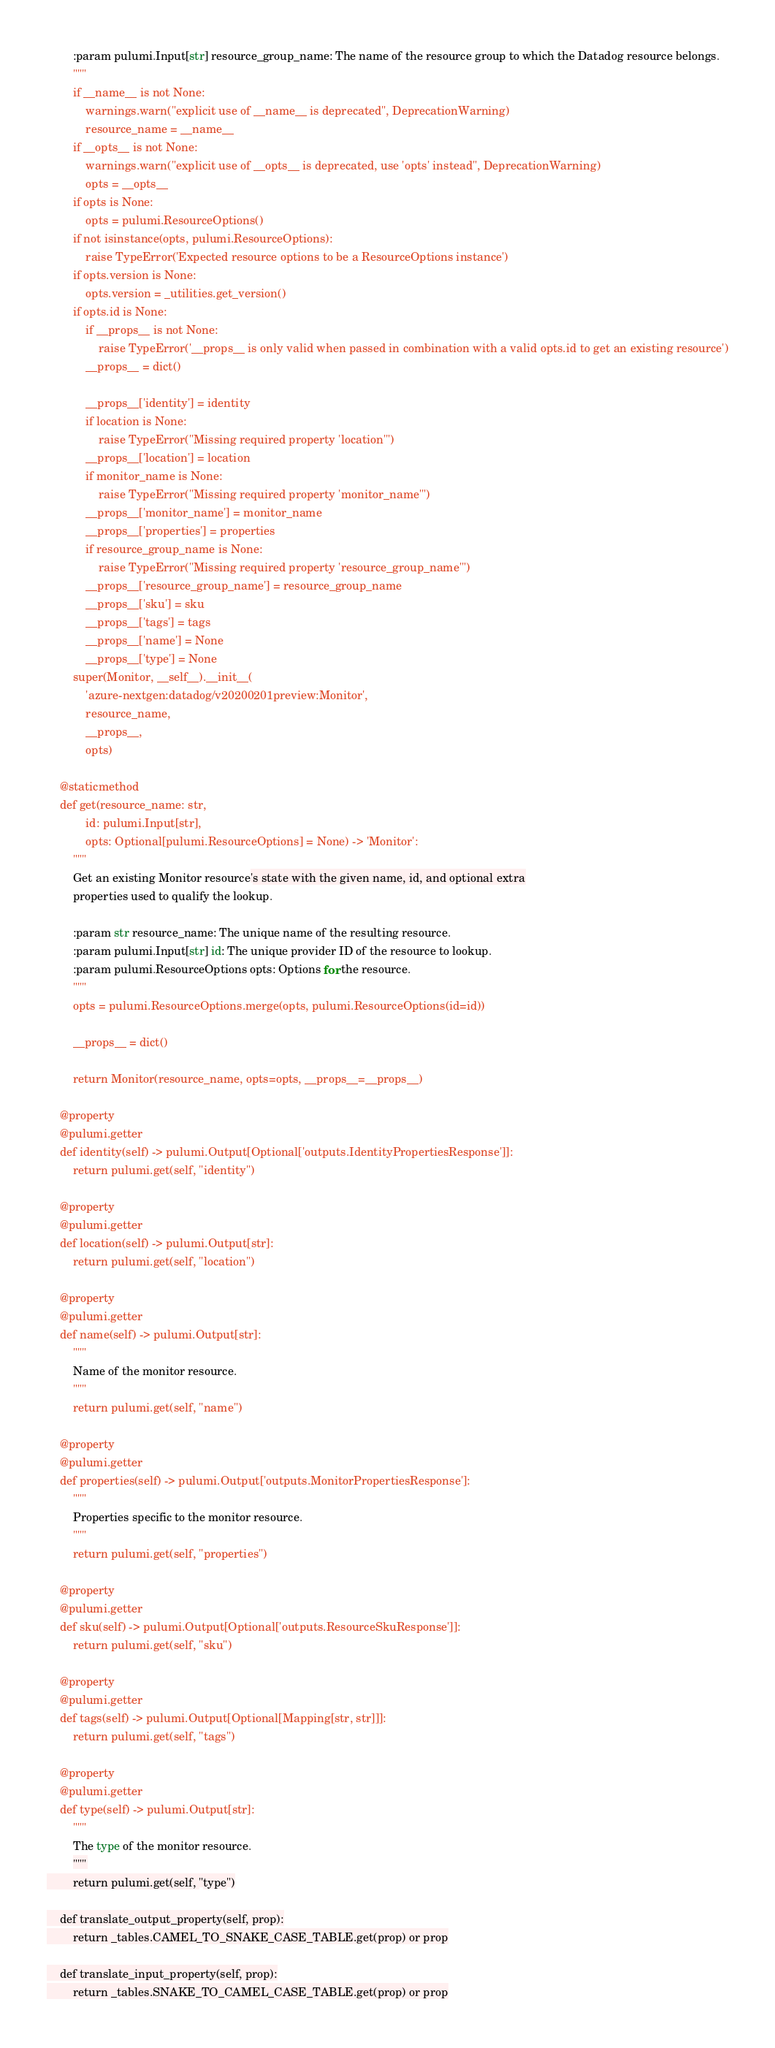<code> <loc_0><loc_0><loc_500><loc_500><_Python_>        :param pulumi.Input[str] resource_group_name: The name of the resource group to which the Datadog resource belongs.
        """
        if __name__ is not None:
            warnings.warn("explicit use of __name__ is deprecated", DeprecationWarning)
            resource_name = __name__
        if __opts__ is not None:
            warnings.warn("explicit use of __opts__ is deprecated, use 'opts' instead", DeprecationWarning)
            opts = __opts__
        if opts is None:
            opts = pulumi.ResourceOptions()
        if not isinstance(opts, pulumi.ResourceOptions):
            raise TypeError('Expected resource options to be a ResourceOptions instance')
        if opts.version is None:
            opts.version = _utilities.get_version()
        if opts.id is None:
            if __props__ is not None:
                raise TypeError('__props__ is only valid when passed in combination with a valid opts.id to get an existing resource')
            __props__ = dict()

            __props__['identity'] = identity
            if location is None:
                raise TypeError("Missing required property 'location'")
            __props__['location'] = location
            if monitor_name is None:
                raise TypeError("Missing required property 'monitor_name'")
            __props__['monitor_name'] = monitor_name
            __props__['properties'] = properties
            if resource_group_name is None:
                raise TypeError("Missing required property 'resource_group_name'")
            __props__['resource_group_name'] = resource_group_name
            __props__['sku'] = sku
            __props__['tags'] = tags
            __props__['name'] = None
            __props__['type'] = None
        super(Monitor, __self__).__init__(
            'azure-nextgen:datadog/v20200201preview:Monitor',
            resource_name,
            __props__,
            opts)

    @staticmethod
    def get(resource_name: str,
            id: pulumi.Input[str],
            opts: Optional[pulumi.ResourceOptions] = None) -> 'Monitor':
        """
        Get an existing Monitor resource's state with the given name, id, and optional extra
        properties used to qualify the lookup.

        :param str resource_name: The unique name of the resulting resource.
        :param pulumi.Input[str] id: The unique provider ID of the resource to lookup.
        :param pulumi.ResourceOptions opts: Options for the resource.
        """
        opts = pulumi.ResourceOptions.merge(opts, pulumi.ResourceOptions(id=id))

        __props__ = dict()

        return Monitor(resource_name, opts=opts, __props__=__props__)

    @property
    @pulumi.getter
    def identity(self) -> pulumi.Output[Optional['outputs.IdentityPropertiesResponse']]:
        return pulumi.get(self, "identity")

    @property
    @pulumi.getter
    def location(self) -> pulumi.Output[str]:
        return pulumi.get(self, "location")

    @property
    @pulumi.getter
    def name(self) -> pulumi.Output[str]:
        """
        Name of the monitor resource.
        """
        return pulumi.get(self, "name")

    @property
    @pulumi.getter
    def properties(self) -> pulumi.Output['outputs.MonitorPropertiesResponse']:
        """
        Properties specific to the monitor resource.
        """
        return pulumi.get(self, "properties")

    @property
    @pulumi.getter
    def sku(self) -> pulumi.Output[Optional['outputs.ResourceSkuResponse']]:
        return pulumi.get(self, "sku")

    @property
    @pulumi.getter
    def tags(self) -> pulumi.Output[Optional[Mapping[str, str]]]:
        return pulumi.get(self, "tags")

    @property
    @pulumi.getter
    def type(self) -> pulumi.Output[str]:
        """
        The type of the monitor resource.
        """
        return pulumi.get(self, "type")

    def translate_output_property(self, prop):
        return _tables.CAMEL_TO_SNAKE_CASE_TABLE.get(prop) or prop

    def translate_input_property(self, prop):
        return _tables.SNAKE_TO_CAMEL_CASE_TABLE.get(prop) or prop

</code> 